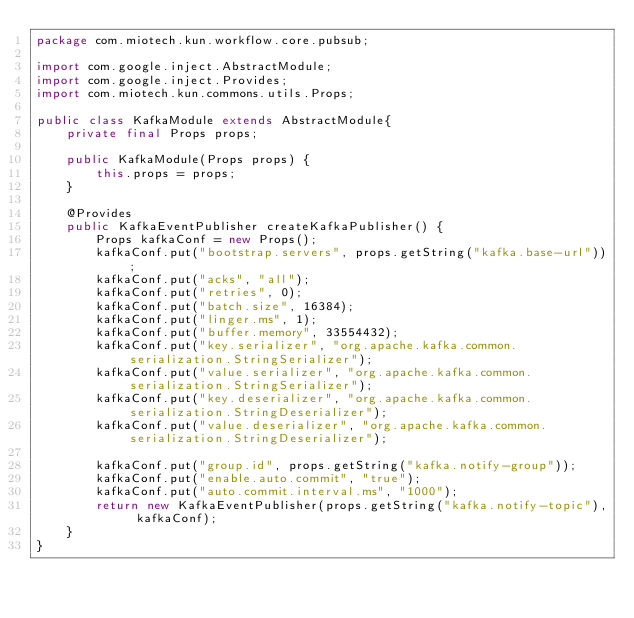Convert code to text. <code><loc_0><loc_0><loc_500><loc_500><_Java_>package com.miotech.kun.workflow.core.pubsub;

import com.google.inject.AbstractModule;
import com.google.inject.Provides;
import com.miotech.kun.commons.utils.Props;

public class KafkaModule extends AbstractModule{
    private final Props props;

    public KafkaModule(Props props) {
        this.props = props;
    }

    @Provides
    public KafkaEventPublisher createKafkaPublisher() {
        Props kafkaConf = new Props();
        kafkaConf.put("bootstrap.servers", props.getString("kafka.base-url"));
        kafkaConf.put("acks", "all");
        kafkaConf.put("retries", 0);
        kafkaConf.put("batch.size", 16384);
        kafkaConf.put("linger.ms", 1);
        kafkaConf.put("buffer.memory", 33554432);
        kafkaConf.put("key.serializer", "org.apache.kafka.common.serialization.StringSerializer");
        kafkaConf.put("value.serializer", "org.apache.kafka.common.serialization.StringSerializer");
        kafkaConf.put("key.deserializer", "org.apache.kafka.common.serialization.StringDeserializer");
        kafkaConf.put("value.deserializer", "org.apache.kafka.common.serialization.StringDeserializer");

        kafkaConf.put("group.id", props.getString("kafka.notify-group"));
        kafkaConf.put("enable.auto.commit", "true");
        kafkaConf.put("auto.commit.interval.ms", "1000");
        return new KafkaEventPublisher(props.getString("kafka.notify-topic"), kafkaConf);
    }
}
</code> 